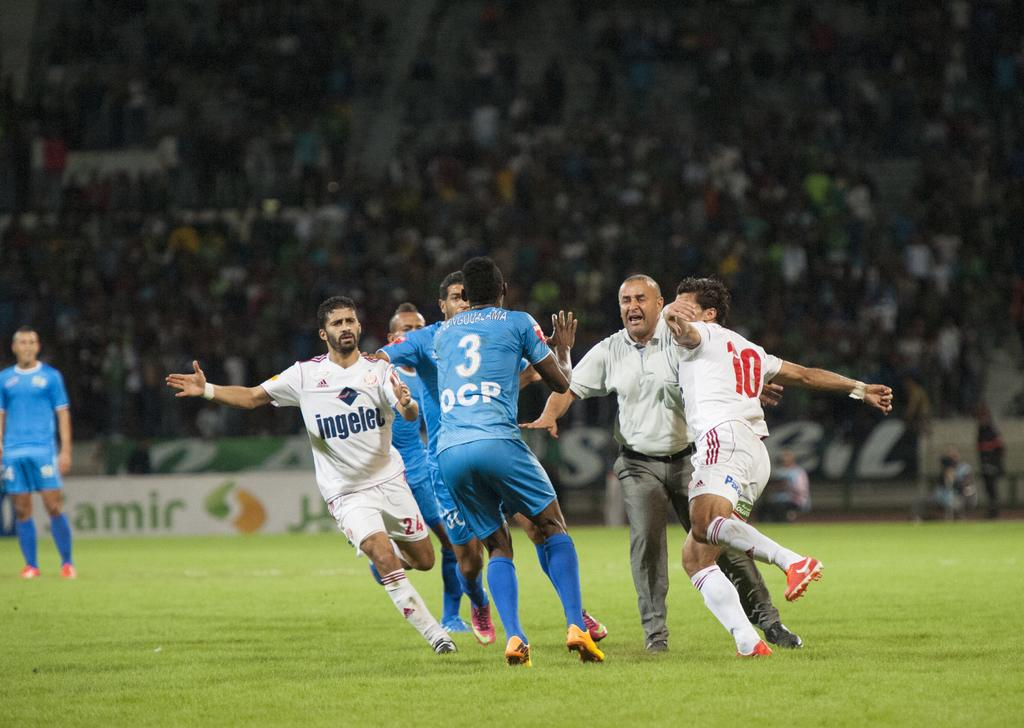<image>
Summarize the visual content of the image. A referee stands between soccer players wearing jerseys with the numbers 3, 10, and 24. 